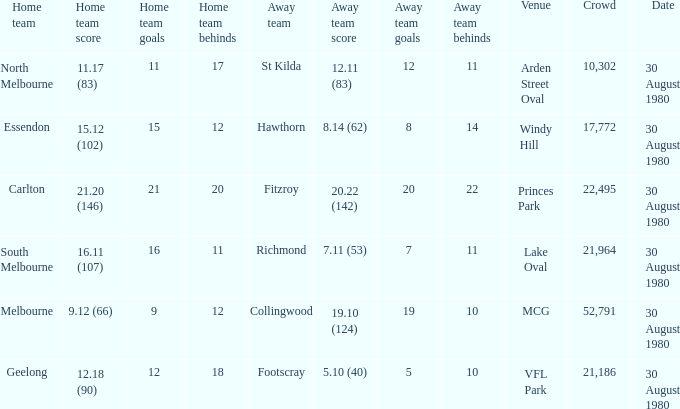Can you parse all the data within this table? {'header': ['Home team', 'Home team score', 'Home team goals', 'Home team behinds', 'Away team', 'Away team score', 'Away team goals', 'Away team behinds', 'Venue', 'Crowd', 'Date'], 'rows': [['North Melbourne', '11.17 (83)', '11', '17', 'St Kilda', '12.11 (83)', '12', '11', 'Arden Street Oval', '10,302', '30 August 1980'], ['Essendon', '15.12 (102)', '15', '12', 'Hawthorn', '8.14 (62)', '8', '14', 'Windy Hill', '17,772', '30 August 1980'], ['Carlton', '21.20 (146)', '21', '20', 'Fitzroy', '20.22 (142)', '20', '22', 'Princes Park', '22,495', '30 August 1980'], ['South Melbourne', '16.11 (107)', '16', '11', 'Richmond', '7.11 (53)', '7', '11', 'Lake Oval', '21,964', '30 August 1980'], ['Melbourne', '9.12 (66)', '9', '12', 'Collingwood', '19.10 (124)', '19', '10', 'MCG', '52,791', '30 August 1980'], ['Geelong', '12.18 (90)', '12', '18', 'Footscray', '5.10 (40)', '5', '10', 'VFL Park', '21,186', '30 August 1980']]} What was the score for south melbourne at home? 16.11 (107). 